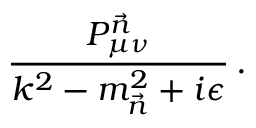Convert formula to latex. <formula><loc_0><loc_0><loc_500><loc_500>\frac { P _ { \mu \nu } ^ { \vec { n } } } { k ^ { 2 } - m _ { \vec { n } } ^ { 2 } + i \epsilon } \, .</formula> 